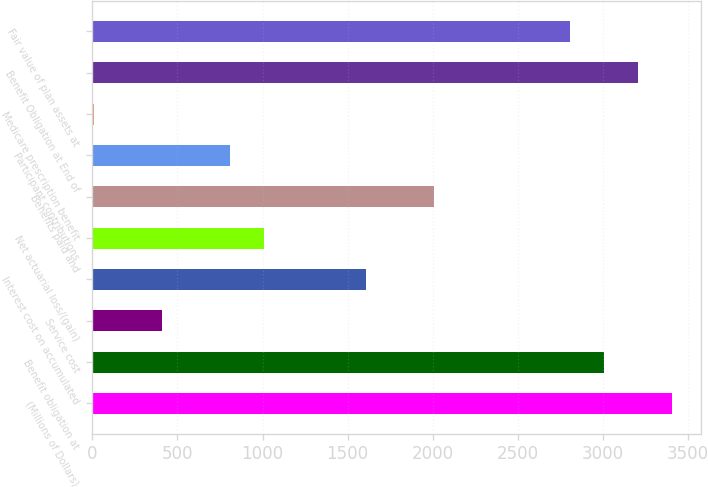<chart> <loc_0><loc_0><loc_500><loc_500><bar_chart><fcel>(Millions of Dollars)<fcel>Benefit obligation at<fcel>Service cost<fcel>Interest cost on accumulated<fcel>Net actuarial loss/(gain)<fcel>Benefits paid and<fcel>Participant contributions<fcel>Medicare prescription benefit<fcel>Benefit Obligation at End of<fcel>Fair value of plan assets at<nl><fcel>3405.6<fcel>3006<fcel>408.6<fcel>1607.4<fcel>1008<fcel>2007<fcel>808.2<fcel>9<fcel>3205.8<fcel>2806.2<nl></chart> 